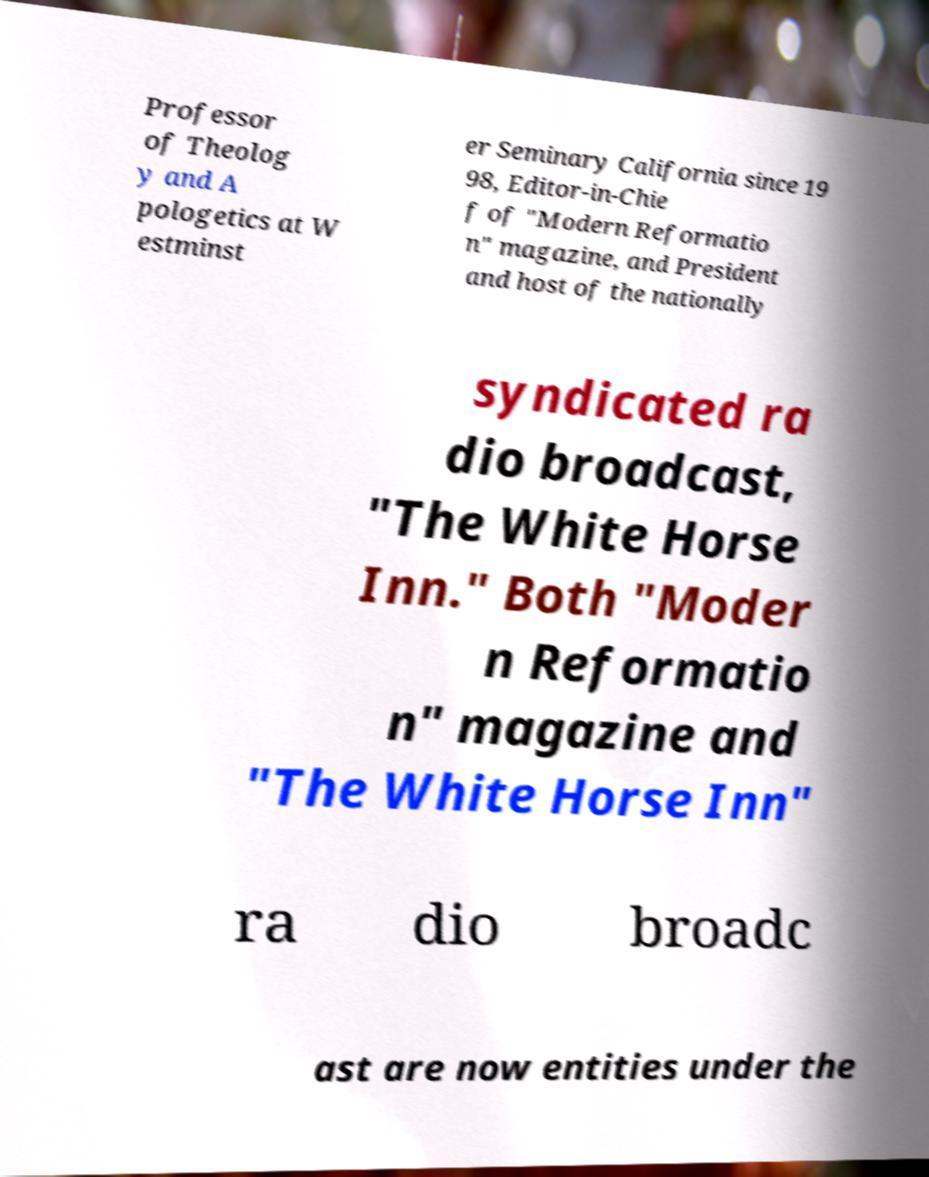Can you accurately transcribe the text from the provided image for me? Professor of Theolog y and A pologetics at W estminst er Seminary California since 19 98, Editor-in-Chie f of "Modern Reformatio n" magazine, and President and host of the nationally syndicated ra dio broadcast, "The White Horse Inn." Both "Moder n Reformatio n" magazine and "The White Horse Inn" ra dio broadc ast are now entities under the 